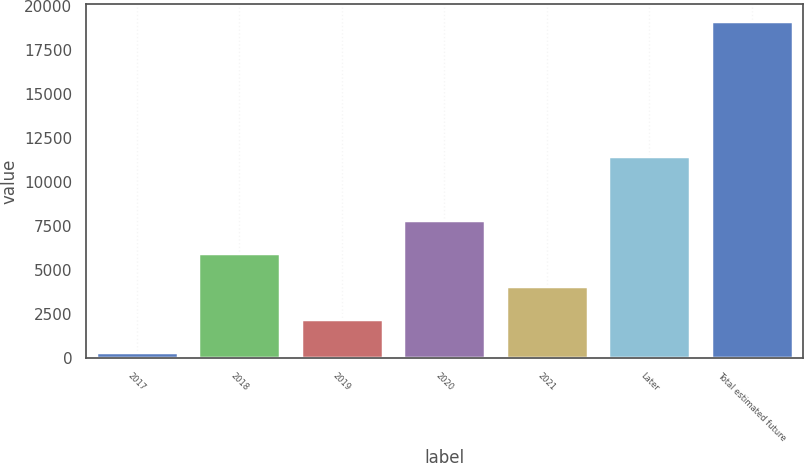<chart> <loc_0><loc_0><loc_500><loc_500><bar_chart><fcel>2017<fcel>2018<fcel>2019<fcel>2020<fcel>2021<fcel>Later<fcel>Total estimated future<nl><fcel>323<fcel>5971.1<fcel>2205.7<fcel>7853.8<fcel>4088.4<fcel>11442<fcel>19150<nl></chart> 